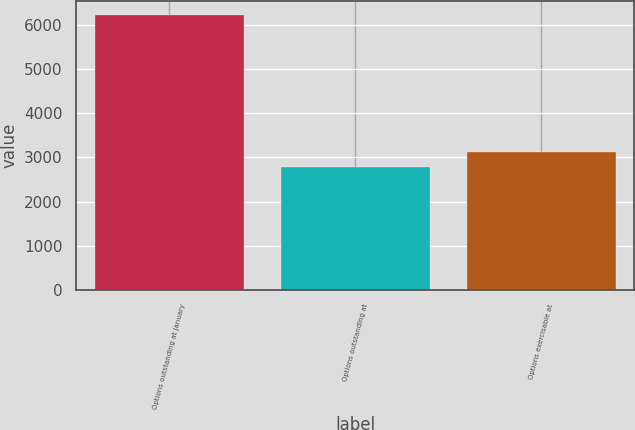<chart> <loc_0><loc_0><loc_500><loc_500><bar_chart><fcel>Options outstanding at January<fcel>Options outstanding at<fcel>Options exercisable at<nl><fcel>6218<fcel>2778<fcel>3122<nl></chart> 